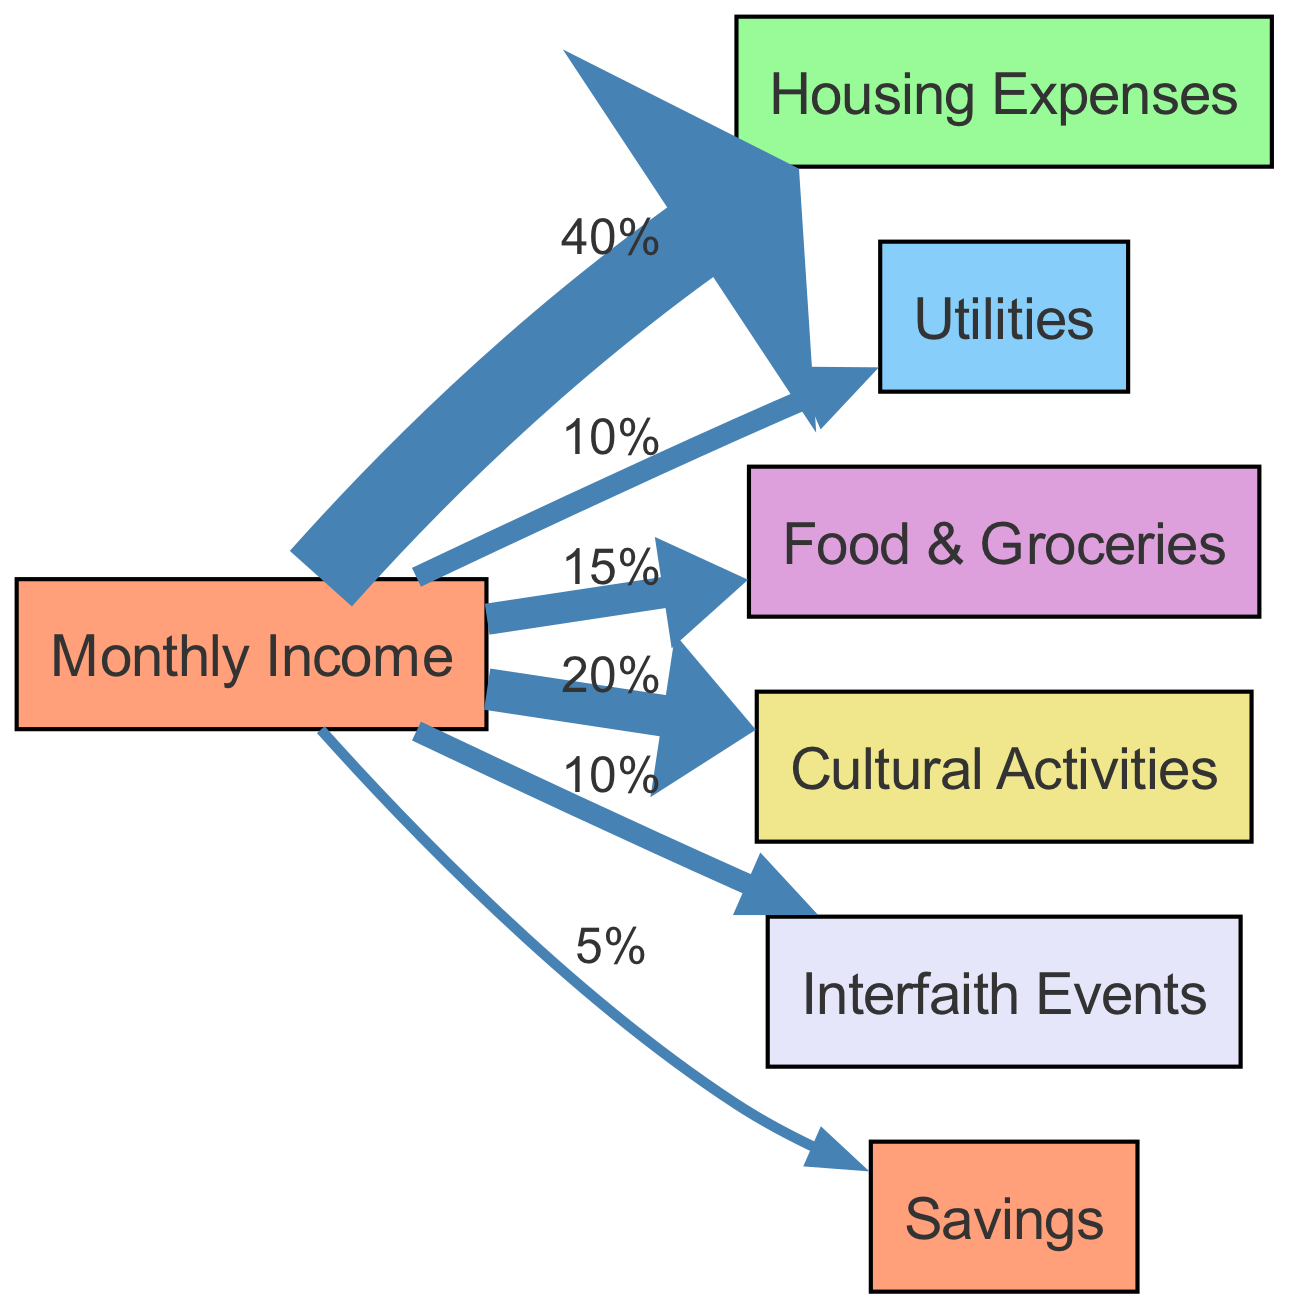What is the percentage allocated to food and groceries? The diagram shows a direct flow from "Monthly Income" to "Food & Groceries" with a value of 15%. This numerical value indicates how much of the monthly income is dedicated to food and groceries.
Answer: 15% How many nodes are present in the diagram? The diagram lists 7 distinct nodes: "Monthly Income", "Housing Expenses", "Utilities", "Food & Groceries", "Cultural Activities", "Interfaith Events", and "Savings". Counting each gives a total of 7 nodes in the diagram.
Answer: 7 What is the total percentage allocated to cultural activities and interfaith events? To find the total percentage, we add the values linked from "Monthly Income" to "Cultural Activities" (20%) and to "Interfaith Events" (10%). Adding these two values together results in a total percentage of 30%.
Answer: 30% Which expense category has the highest allocation from monthly income? By reviewing the flows from "Monthly Income", the highest percentage directed towards a single category is "Housing Expenses", which receives 40%, making it the largest allocation in the diagram.
Answer: Housing Expenses What is the flow percentage allocated to savings? The edge from "Monthly Income" to "Savings" indicates a flow value of 5%. Thus, 5% of the monthly income is designated for savings.
Answer: 5% What is the connection between cultural activities and interfaith events? Both "Cultural Activities" and "Interfaith Events" receive their allocations from the single node "Monthly Income". This means they are both outcomes of the same financial source, representing parts of the overall budget.
Answer: Monthly Income Which two expenses have the same allocation percentage? The diagram indicates that "Utilities" and "Interfaith Events" each receive 10% from "Monthly Income". Therefore, they both share the same allocation percentage in the budget.
Answer: Utilities and Interfaith Events What is the percentage of income allocated to housing expenses compared to cultural activities? "Housing Expenses" receives 40% and "Cultural Activities" receives 20%. The comparison shows that housing expenses are twice the percentage allocated to cultural activities, indicating a stronger focus on housing in the budget.
Answer: 40% to 20% 